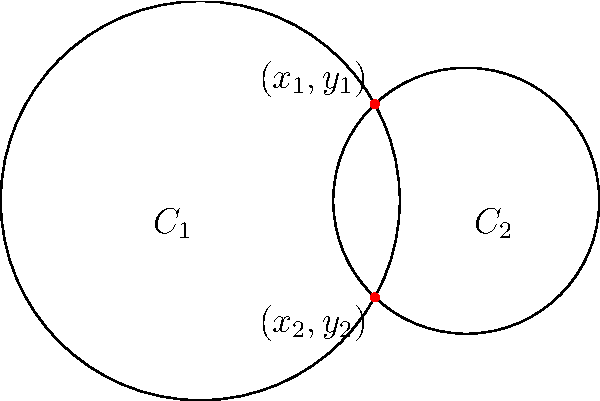As a curious amateur programmer with a knack for detective work, you've encountered a geometric puzzle. Two circles, $C_1$ and $C_2$, are represented by the following equations:

$C_1: x^2 + y^2 = 9$
$C_2: (x-4)^2 + y^2 = 4$

Your task is to find the coordinates of the intersection points $(x_1,y_1)$ and $(x_2,y_2)$. How would you approach this problem using your programming and debugging skills? Let's approach this step-by-step:

1) First, we recognize that these equations represent circles:
   $C_1$ is centered at (0,0) with radius 3
   $C_2$ is centered at (4,0) with radius 2

2) To find the intersection points, we need to solve these equations simultaneously. As a programmer, we can think of this as "debugging" the system to find where both equations are true.

3) Subtracting the second equation from the first:
   $(x^2 + y^2) - ((x-4)^2 + y^2) = 9 - 4$
   $x^2 - (x^2 - 8x + 16) = 5$
   $8x - 16 = 5$
   $8x = 21$
   $x = \frac{21}{8} = 2.625$

4) Now that we know the x-coordinate, we can substitute it back into either original equation. Let's use $C_1$:
   $(2.625)^2 + y^2 = 9$
   $y^2 = 9 - 6.890625 = 2.109375$
   $y = \pm\sqrt{2.109375} \approx \pm1.4525$

5) Therefore, the two intersection points are:
   $(x_1,y_1) = (2.625, 1.4525)$
   $(x_2,y_2) = (2.625, -1.4525)$

As a programmer, we could verify this solution by writing a simple program to plug these values back into both original equations and check if they hold true (within a small margin of error for floating-point calculations).
Answer: $(2.625, 1.4525)$ and $(2.625, -1.4525)$ 